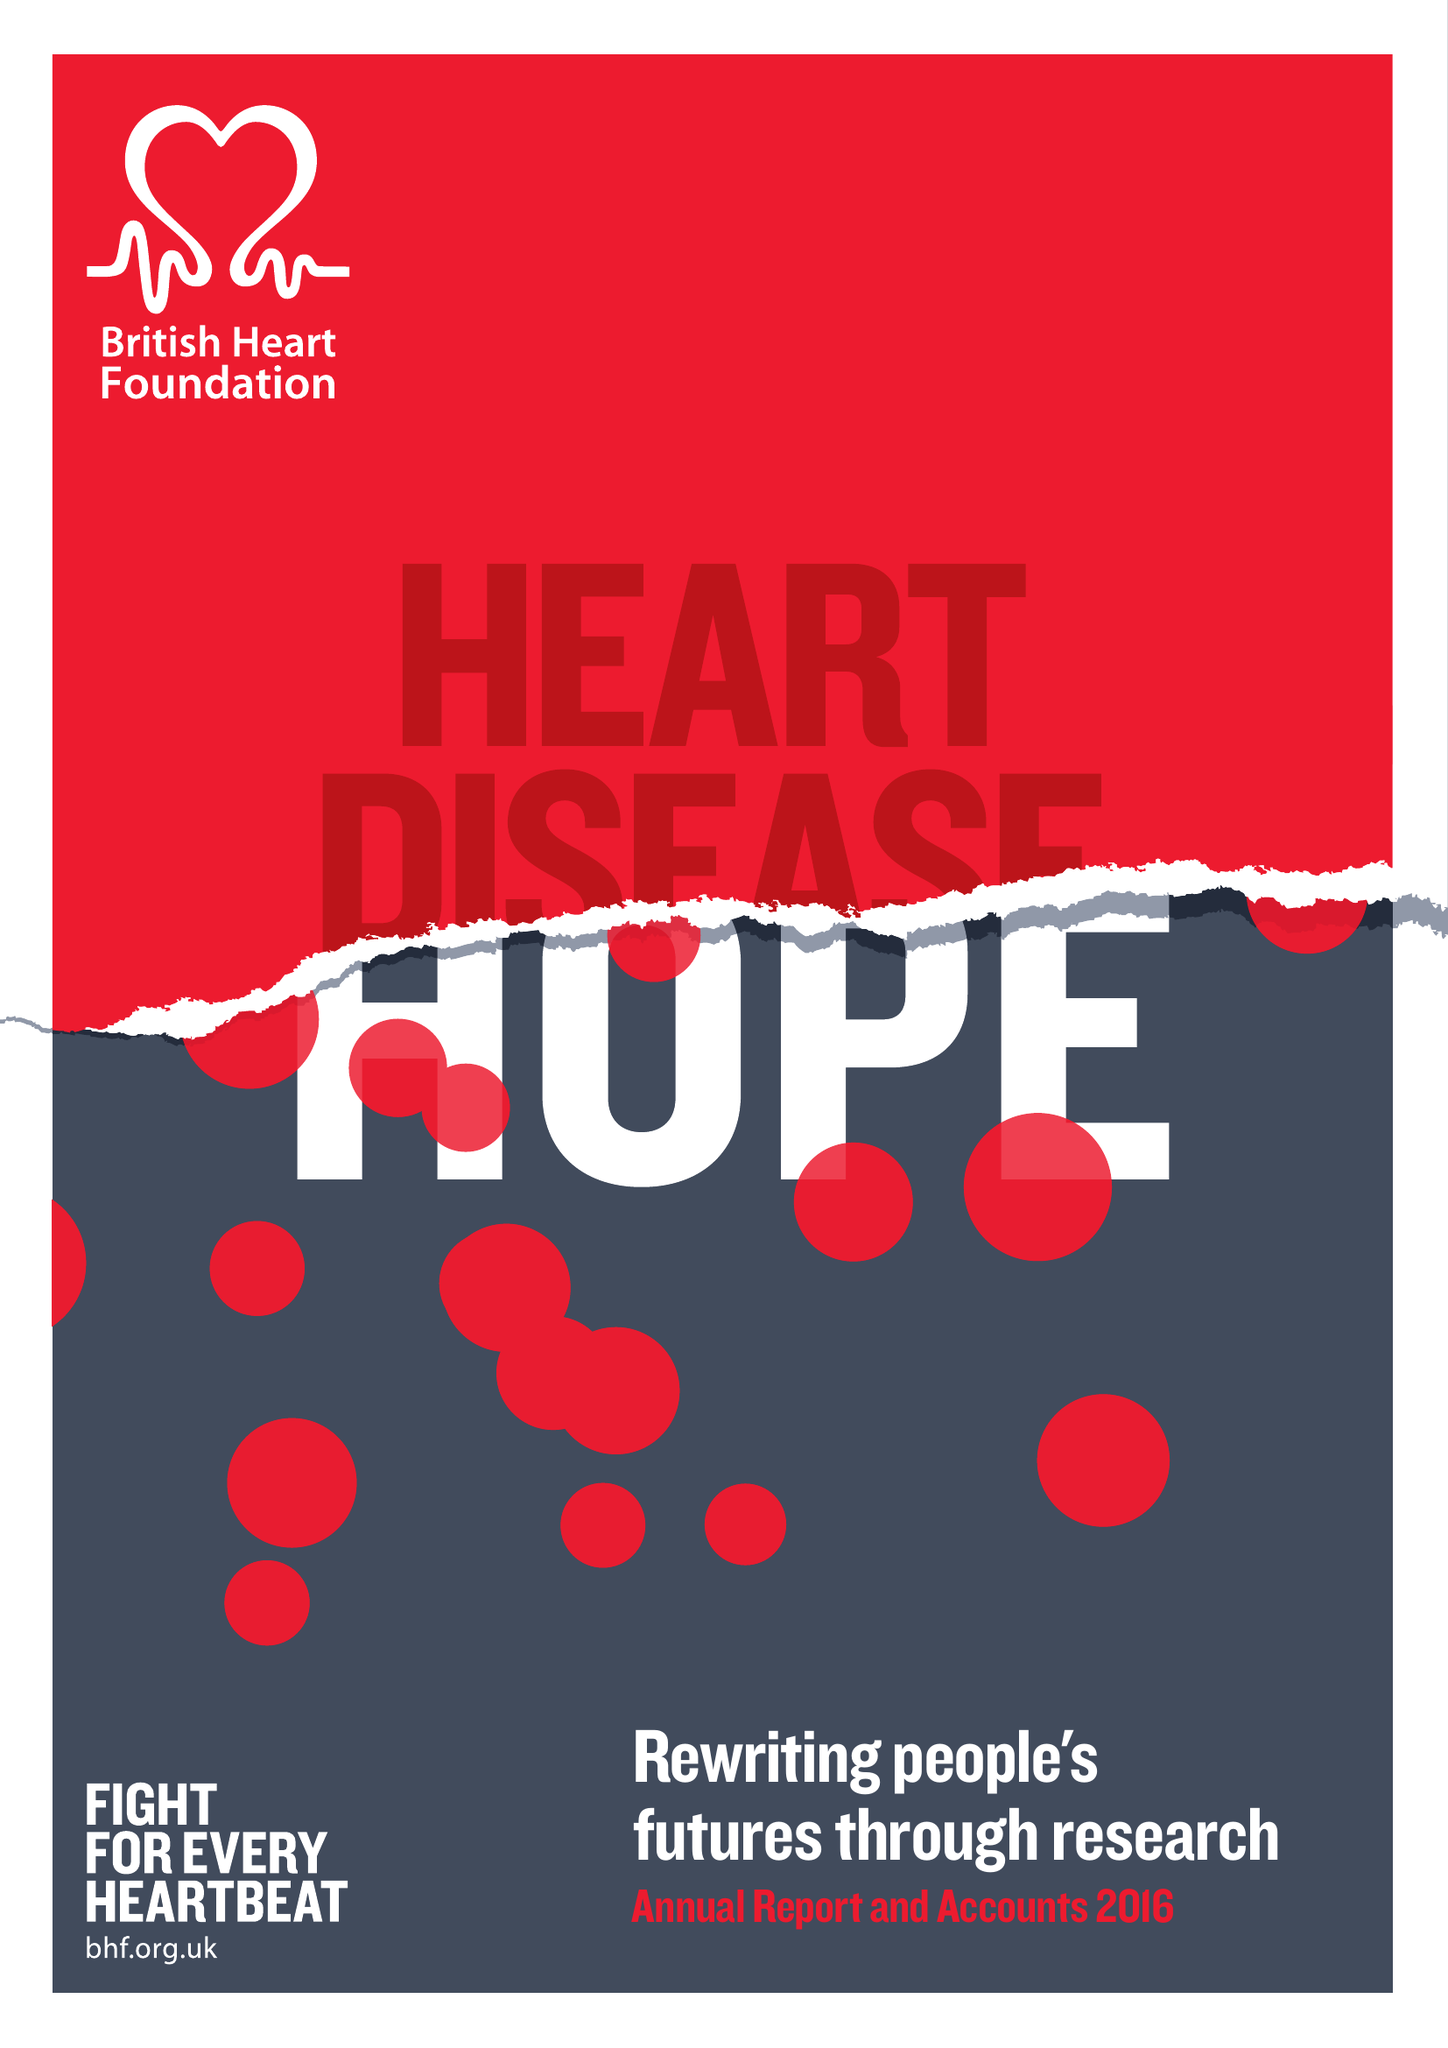What is the value for the address__street_line?
Answer the question using a single word or phrase. 180 HAMPSTEAD ROAD 